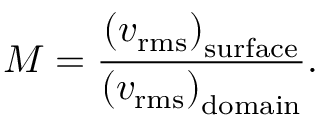<formula> <loc_0><loc_0><loc_500><loc_500>M = \frac { \left ( v _ { r m s } \right ) _ { s u r f a c e } } { \left ( v _ { r m s } \right ) _ { d o m a i n } } .</formula> 